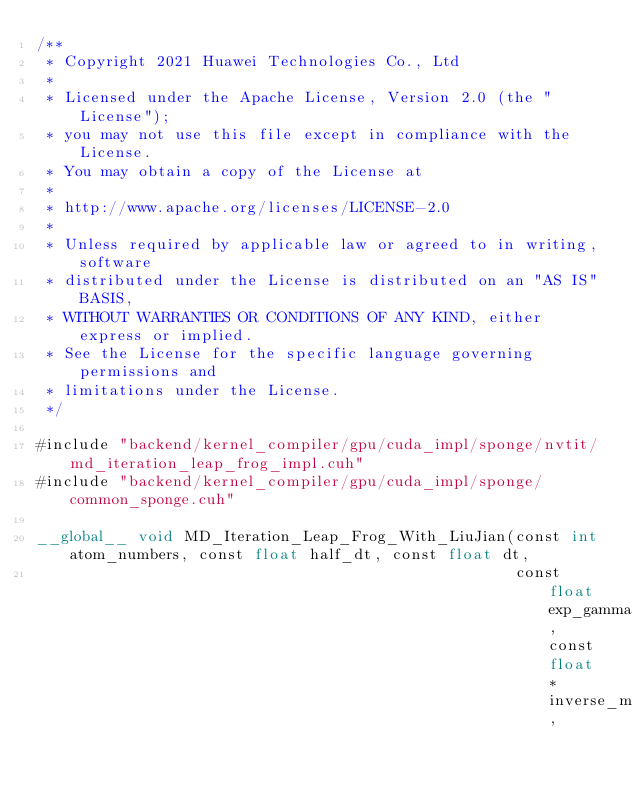Convert code to text. <code><loc_0><loc_0><loc_500><loc_500><_Cuda_>/**
 * Copyright 2021 Huawei Technologies Co., Ltd
 *
 * Licensed under the Apache License, Version 2.0 (the "License");
 * you may not use this file except in compliance with the License.
 * You may obtain a copy of the License at
 *
 * http://www.apache.org/licenses/LICENSE-2.0
 *
 * Unless required by applicable law or agreed to in writing, software
 * distributed under the License is distributed on an "AS IS" BASIS,
 * WITHOUT WARRANTIES OR CONDITIONS OF ANY KIND, either express or implied.
 * See the License for the specific language governing permissions and
 * limitations under the License.
 */

#include "backend/kernel_compiler/gpu/cuda_impl/sponge/nvtit/md_iteration_leap_frog_impl.cuh"
#include "backend/kernel_compiler/gpu/cuda_impl/sponge/common_sponge.cuh"

__global__ void MD_Iteration_Leap_Frog_With_LiuJian(const int atom_numbers, const float half_dt, const float dt,
                                                    const float exp_gamma, const float *inverse_mass,</code> 